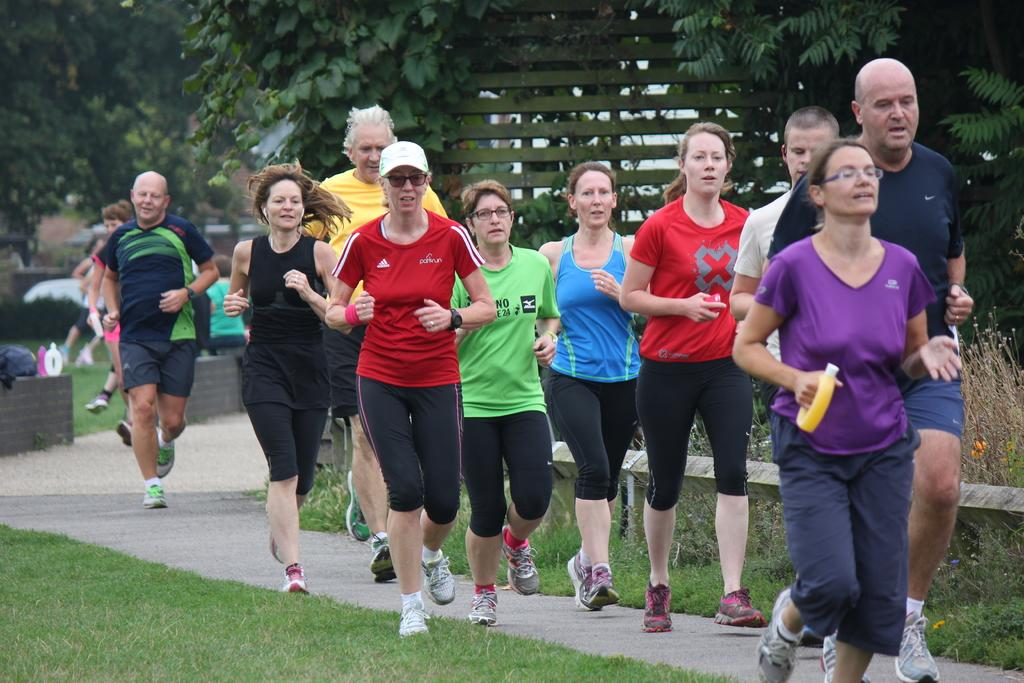What are the people in the image doing? The people in the image are running. What type of surface can be seen beneath the people? There is grass visible in the image. What other types of vegetation are present in the image? There are plants in the image. What can be seen in the background of the image? There are trees and objects on the wall in the background of the image. What type of ship can be seen sailing in the background of the image? There is no ship present in the image; it features people running on grass with trees and objects on the wall in the background. How do the fairies feel about the people running in the image? There are no fairies present in the image, so their feelings cannot be determined. 